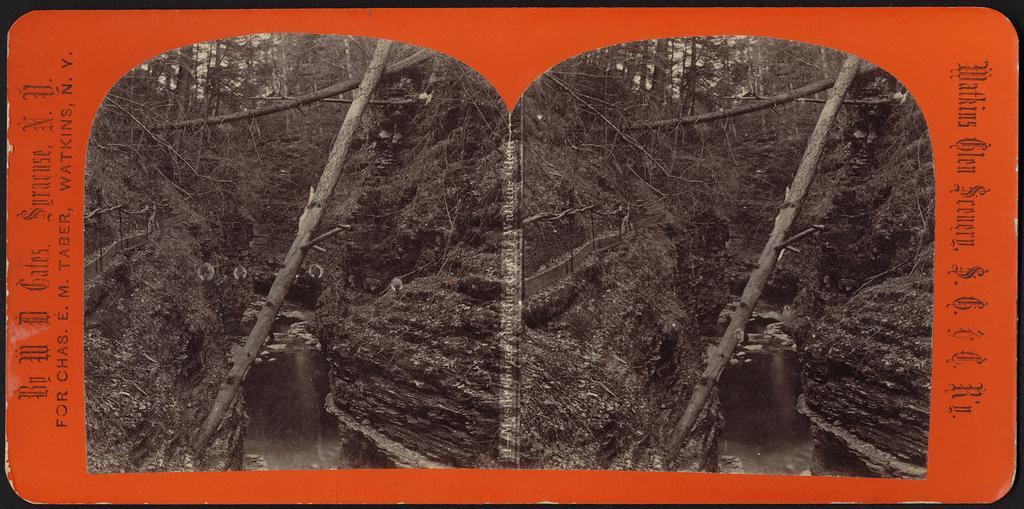Could you give a brief overview of what you see in this image? In this image we can see a poster. On the sides we can see text. Also there are two same images. On the image we can see trees. Also there is water. 